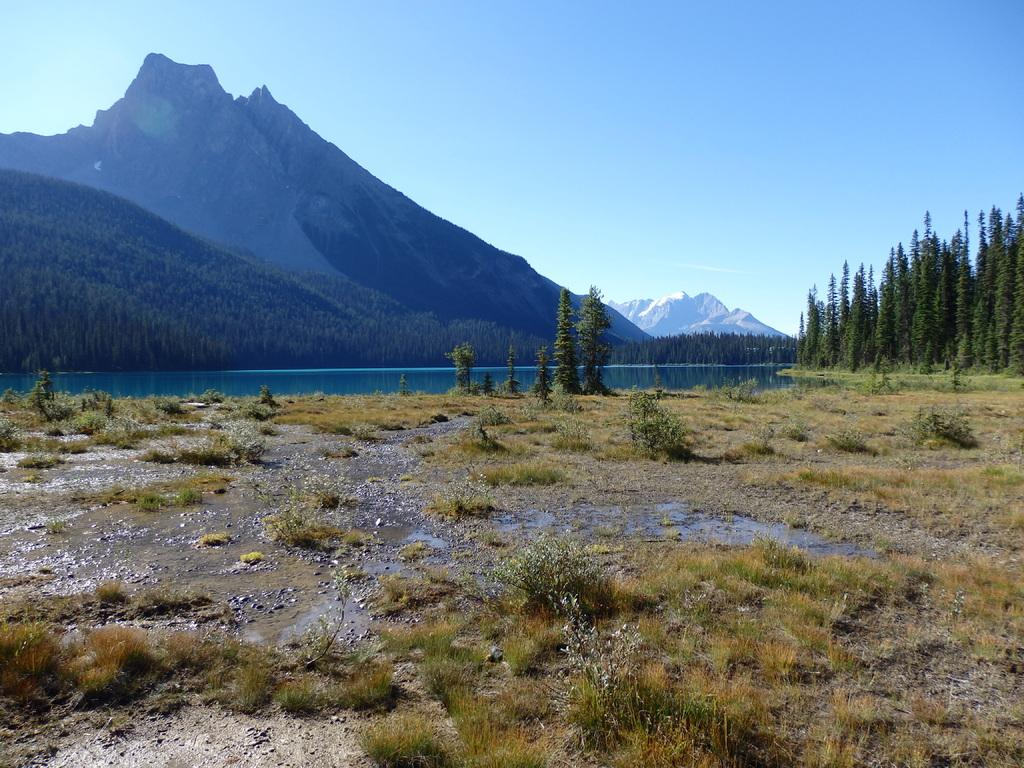What type of natural elements can be seen in the image? There are trees and plants in the image. What body of water is present in the image? There is a lake in the image. What geographical feature is located in the middle of the image? There are hills in the middle of the image. What is visible at the top of the image? The sky is visible at the top of the image. What type of jeans is the person wearing in the image? There is no person wearing jeans in the image; it features a natural landscape with trees, plants, a lake, and hills. What arithmetic problem is being solved in the image? There is no arithmetic problem present in the image; it is a landscape scene without any mathematical elements. 